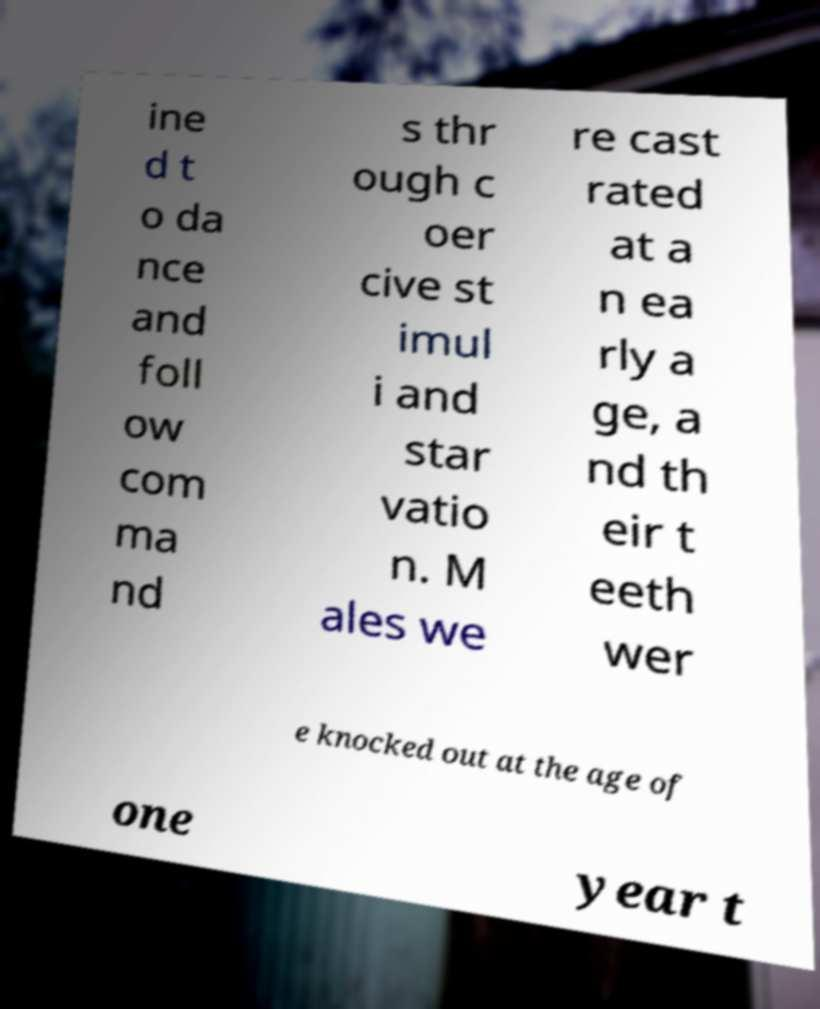There's text embedded in this image that I need extracted. Can you transcribe it verbatim? ine d t o da nce and foll ow com ma nd s thr ough c oer cive st imul i and star vatio n. M ales we re cast rated at a n ea rly a ge, a nd th eir t eeth wer e knocked out at the age of one year t 